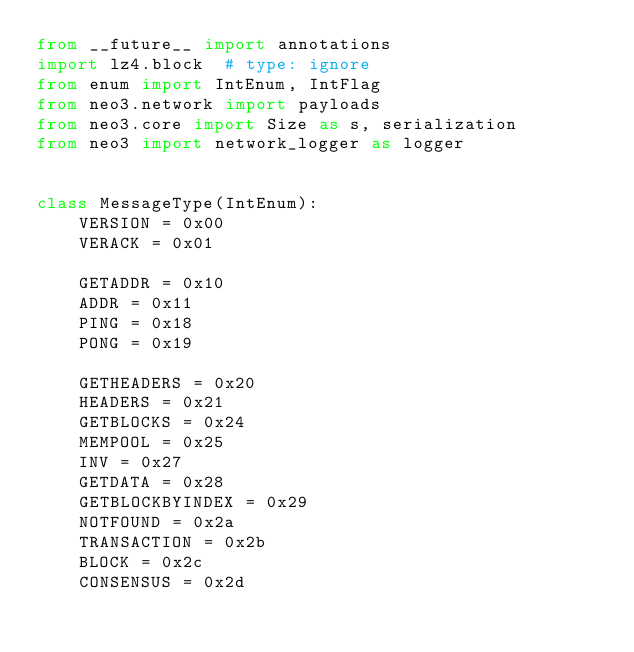<code> <loc_0><loc_0><loc_500><loc_500><_Python_>from __future__ import annotations
import lz4.block  # type: ignore
from enum import IntEnum, IntFlag
from neo3.network import payloads
from neo3.core import Size as s, serialization
from neo3 import network_logger as logger


class MessageType(IntEnum):
    VERSION = 0x00
    VERACK = 0x01

    GETADDR = 0x10
    ADDR = 0x11
    PING = 0x18
    PONG = 0x19

    GETHEADERS = 0x20
    HEADERS = 0x21
    GETBLOCKS = 0x24
    MEMPOOL = 0x25
    INV = 0x27
    GETDATA = 0x28
    GETBLOCKBYINDEX = 0x29
    NOTFOUND = 0x2a
    TRANSACTION = 0x2b
    BLOCK = 0x2c
    CONSENSUS = 0x2d</code> 